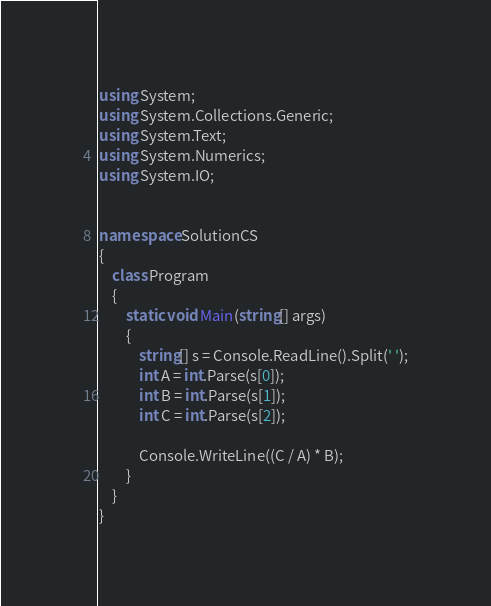Convert code to text. <code><loc_0><loc_0><loc_500><loc_500><_C#_>using System;
using System.Collections.Generic;
using System.Text;
using System.Numerics;
using System.IO;


namespace SolutionCS
{
    class Program
    {
        static void Main(string[] args)
        {
            string[] s = Console.ReadLine().Split(' ');
            int A = int.Parse(s[0]);
            int B = int.Parse(s[1]);
            int C = int.Parse(s[2]);

            Console.WriteLine((C / A) * B);
        }
    }
}
</code> 